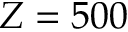Convert formula to latex. <formula><loc_0><loc_0><loc_500><loc_500>Z = 5 0 0</formula> 